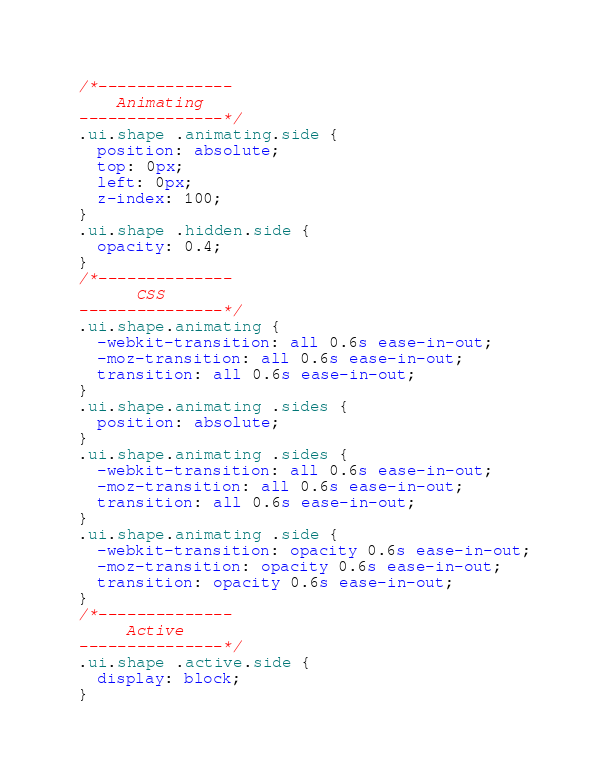Convert code to text. <code><loc_0><loc_0><loc_500><loc_500><_CSS_>/*--------------
    Animating
---------------*/
.ui.shape .animating.side {
  position: absolute;
  top: 0px;
  left: 0px;
  z-index: 100;
}
.ui.shape .hidden.side {
  opacity: 0.4;
}
/*--------------
      CSS
---------------*/
.ui.shape.animating {
  -webkit-transition: all 0.6s ease-in-out;
  -moz-transition: all 0.6s ease-in-out;
  transition: all 0.6s ease-in-out;
}
.ui.shape.animating .sides {
  position: absolute;
}
.ui.shape.animating .sides {
  -webkit-transition: all 0.6s ease-in-out;
  -moz-transition: all 0.6s ease-in-out;
  transition: all 0.6s ease-in-out;
}
.ui.shape.animating .side {
  -webkit-transition: opacity 0.6s ease-in-out;
  -moz-transition: opacity 0.6s ease-in-out;
  transition: opacity 0.6s ease-in-out;
}
/*--------------
     Active
---------------*/
.ui.shape .active.side {
  display: block;
}
</code> 